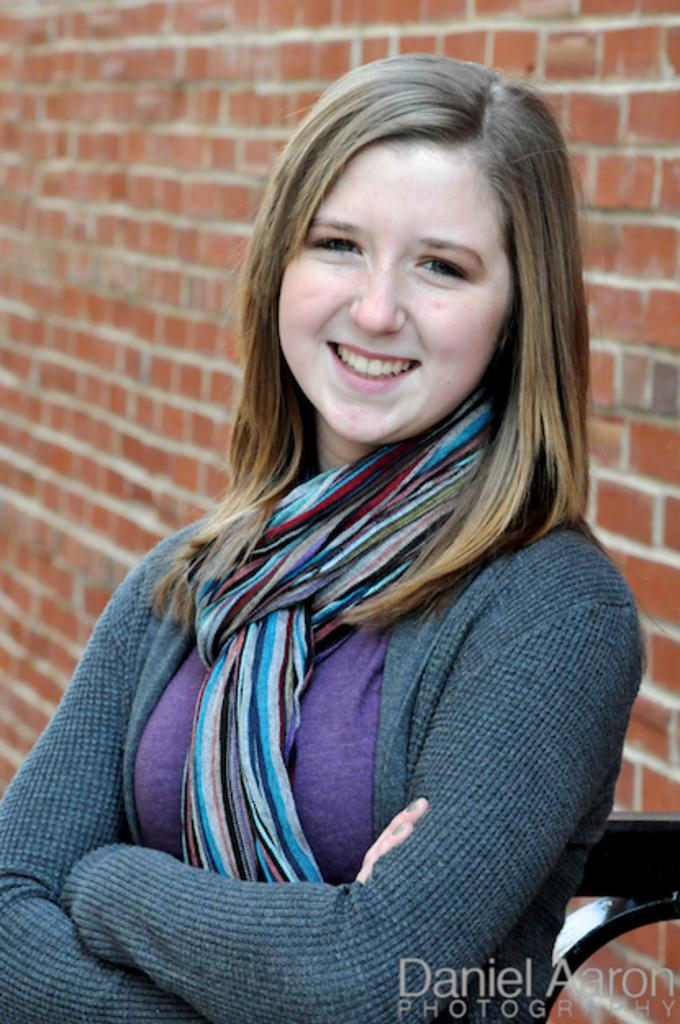Who is present in the image? There is a woman in the image. What is the woman wearing on her upper body? The woman is wearing a grey sweatshirt. What accessory is the woman wearing around her neck? The woman is wearing a scarf. What type of structure can be seen in the background of the image? There is a brick wall in the image. How many bears are helping the woman in the image? There are no bears present in the image, and therefore no assistance from bears can be observed. 